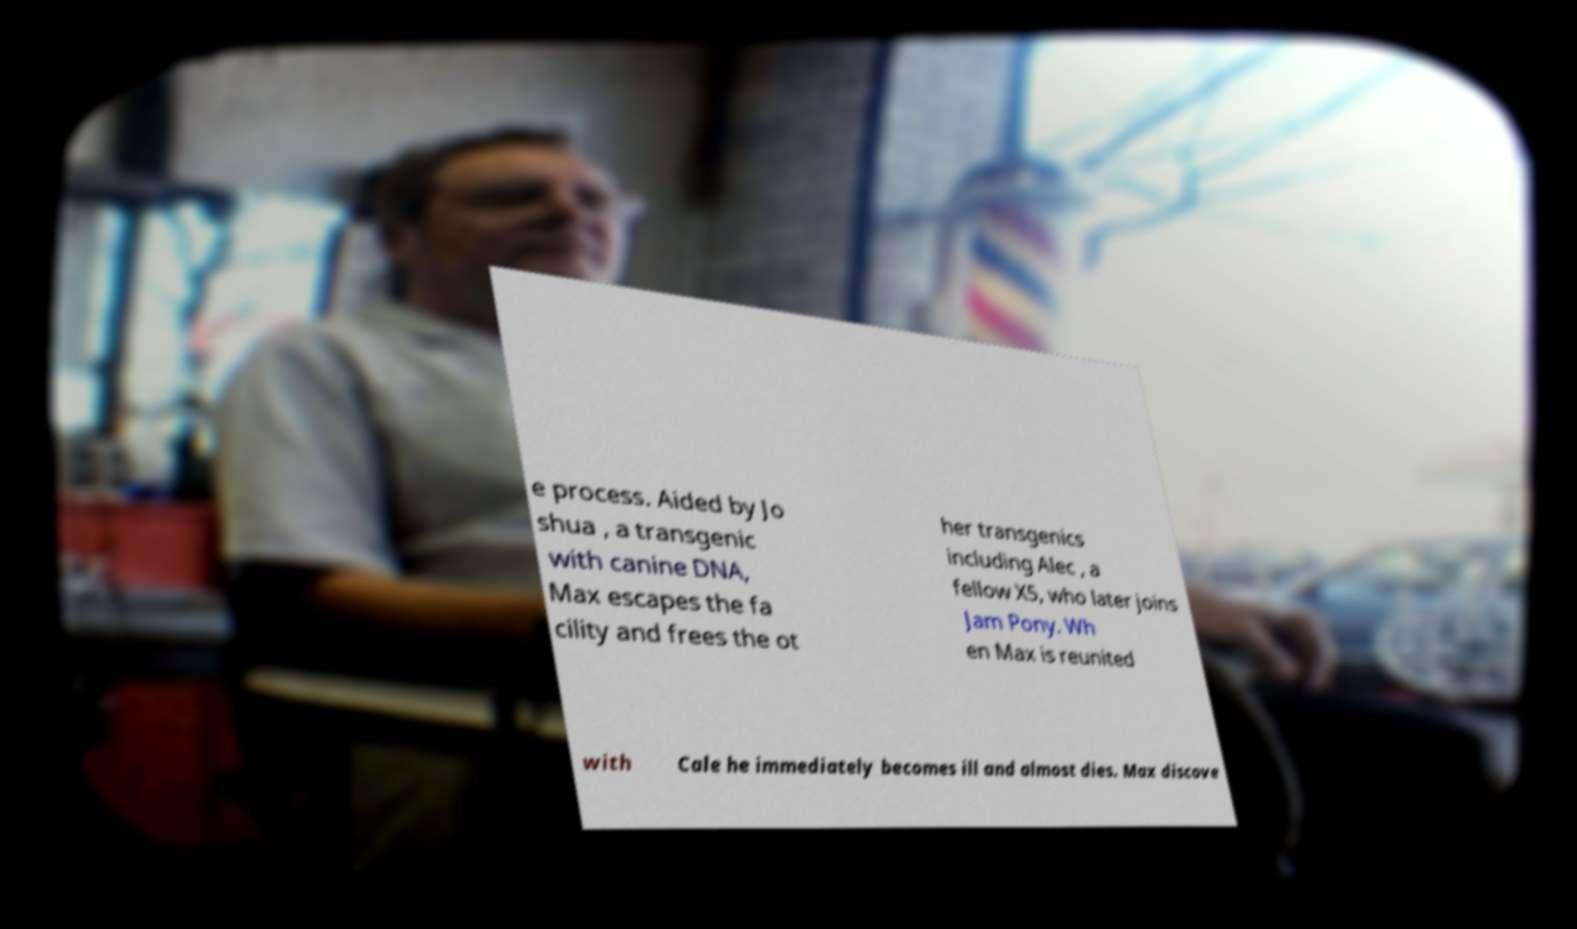Could you assist in decoding the text presented in this image and type it out clearly? e process. Aided by Jo shua , a transgenic with canine DNA, Max escapes the fa cility and frees the ot her transgenics including Alec , a fellow X5, who later joins Jam Pony. Wh en Max is reunited with Cale he immediately becomes ill and almost dies. Max discove 